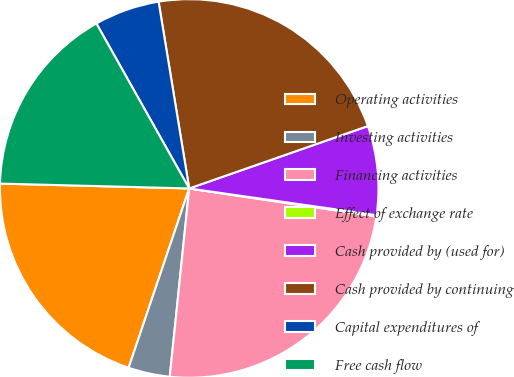Convert chart to OTSL. <chart><loc_0><loc_0><loc_500><loc_500><pie_chart><fcel>Operating activities<fcel>Investing activities<fcel>Financing activities<fcel>Effect of exchange rate<fcel>Cash provided by (used for)<fcel>Cash provided by continuing<fcel>Capital expenditures of<fcel>Free cash flow<nl><fcel>20.22%<fcel>3.55%<fcel>24.27%<fcel>0.11%<fcel>7.6%<fcel>22.24%<fcel>5.57%<fcel>16.43%<nl></chart> 